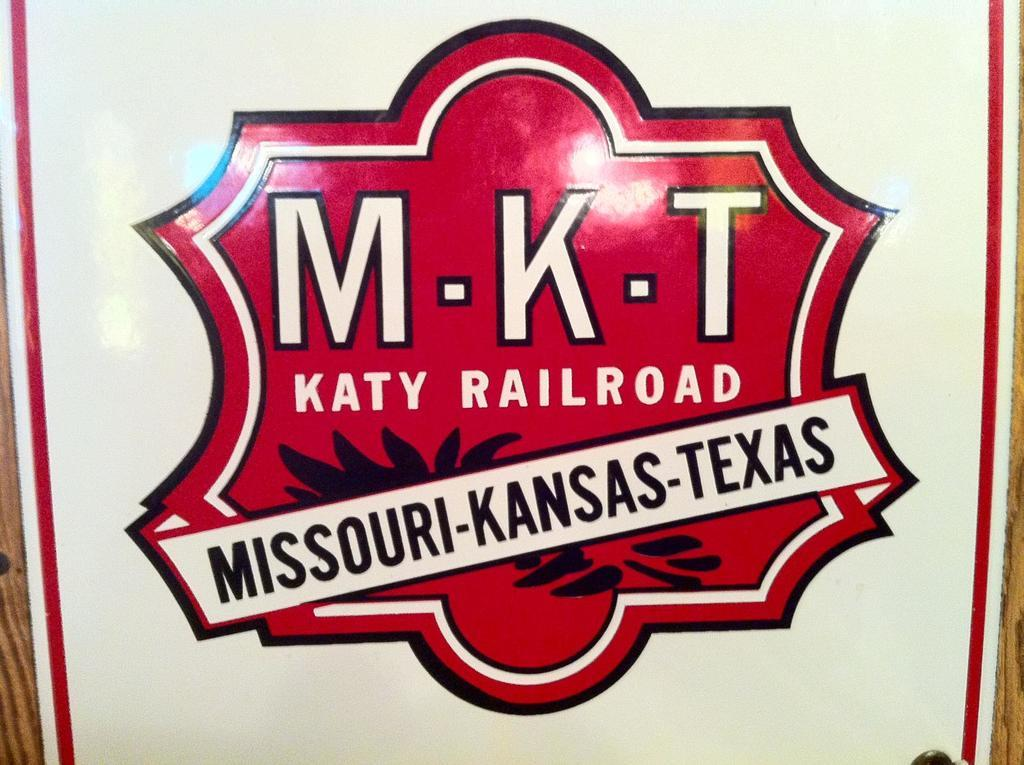<image>
Present a compact description of the photo's key features. The Missouri kansas Texas Katy Railroad red steel sign 